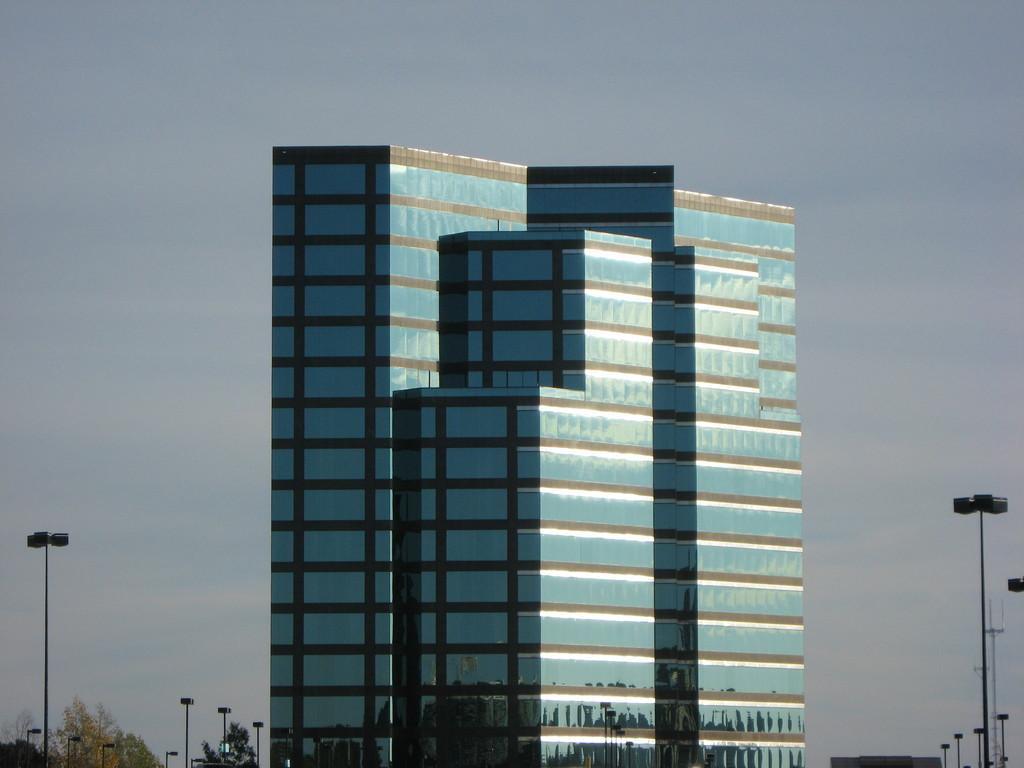What type of structures are present in the image? There are buildings in the image. What can be seen on both sides of the buildings? There are poles on both sides of the buildings. What type of vegetation is visible to the left of the buildings? There are trees to the left of the buildings. What is visible in the background of the image? The sky is visible in the background of the image. Can you see any flowers growing in the ocean near the buildings in the image? There is no ocean or flowers present in the image; it features buildings, poles, trees, and the sky. 